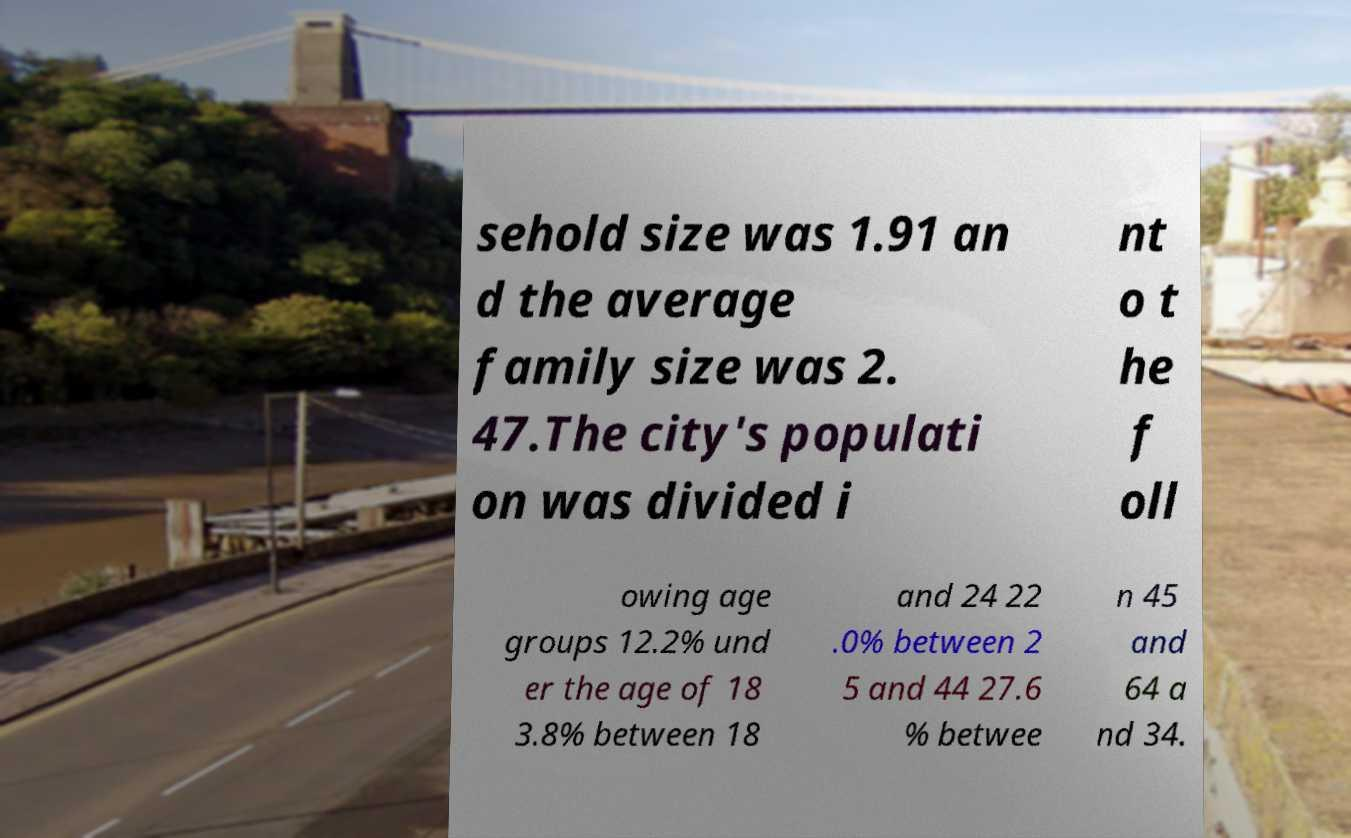I need the written content from this picture converted into text. Can you do that? sehold size was 1.91 an d the average family size was 2. 47.The city's populati on was divided i nt o t he f oll owing age groups 12.2% und er the age of 18 3.8% between 18 and 24 22 .0% between 2 5 and 44 27.6 % betwee n 45 and 64 a nd 34. 